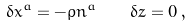Convert formula to latex. <formula><loc_0><loc_0><loc_500><loc_500>\delta x ^ { a } = - \varrho n ^ { a } \quad \delta z = 0 \, ,</formula> 